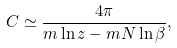Convert formula to latex. <formula><loc_0><loc_0><loc_500><loc_500>C \simeq \frac { 4 \pi } { m \ln z - m N \ln \beta } ,</formula> 